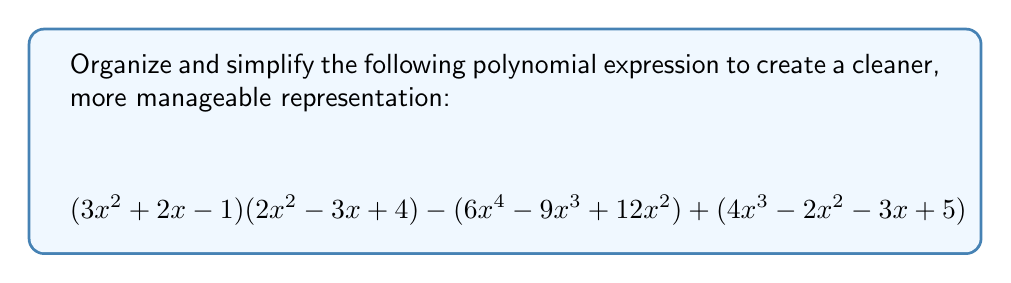Teach me how to tackle this problem. Let's approach this step-by-step to organize and simplify the expression:

1) First, let's expand the product $(3x^2 + 2x - 1)(2x^2 - 3x + 4)$:
   $$(3x^2 + 2x - 1)(2x^2 - 3x + 4) = 6x^4 - 9x^3 + 12x^2 + 4x^3 - 6x^2 + 8x - 2x^3 + 3x^2 - 4$$
   $$= 6x^4 - 7x^3 + 9x^2 + 8x - 4$$

2) Now, let's rewrite our entire expression using this expansion:
   $$(6x^4 - 7x^3 + 9x^2 + 8x - 4) - (6x^4 - 9x^3 + 12x^2) + (4x^3 - 2x^2 - 3x + 5)$$

3) Let's group like terms:
   $$6x^4 - 7x^3 + 9x^2 + 8x - 4$$
   $$- 6x^4 + 9x^3 - 12x^2$$
   $$+ 4x^3 - 2x^2 - 3x + 5$$

4) Now, let's add these grouped terms:
   $$6x^4 - 7x^3 + 9x^2 + 8x - 4$$
   $$-6x^4 + 9x^3 - 12x^2$$
   $$+ 4x^3 - 2x^2 - 3x + 5$$
   $$= 0x^4 + 6x^3 - 5x^2 + 5x + 1$$

5) Simplify by removing the zero term:
   $$6x^3 - 5x^2 + 5x + 1$$

This is our final, simplified polynomial expression.
Answer: $$6x^3 - 5x^2 + 5x + 1$$ 